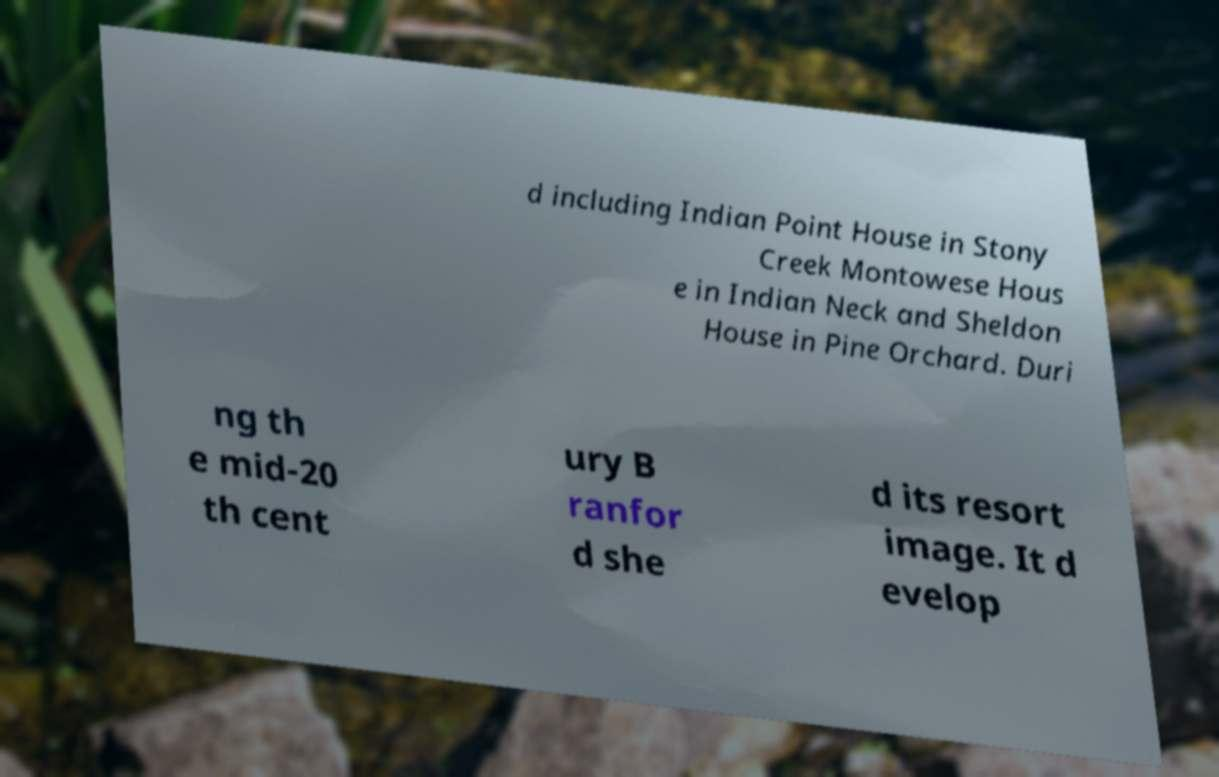Can you read and provide the text displayed in the image?This photo seems to have some interesting text. Can you extract and type it out for me? d including Indian Point House in Stony Creek Montowese Hous e in Indian Neck and Sheldon House in Pine Orchard. Duri ng th e mid-20 th cent ury B ranfor d she d its resort image. It d evelop 